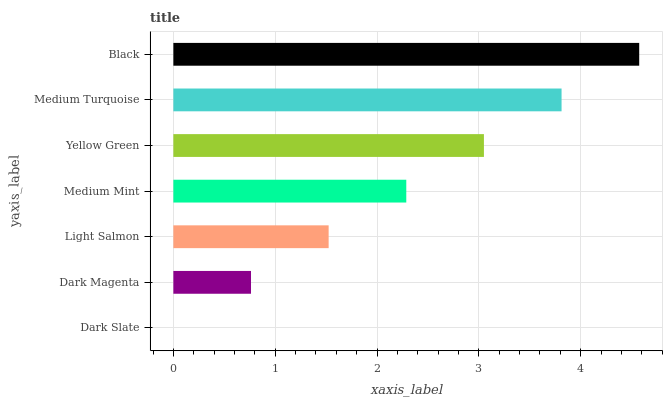Is Dark Slate the minimum?
Answer yes or no. Yes. Is Black the maximum?
Answer yes or no. Yes. Is Dark Magenta the minimum?
Answer yes or no. No. Is Dark Magenta the maximum?
Answer yes or no. No. Is Dark Magenta greater than Dark Slate?
Answer yes or no. Yes. Is Dark Slate less than Dark Magenta?
Answer yes or no. Yes. Is Dark Slate greater than Dark Magenta?
Answer yes or no. No. Is Dark Magenta less than Dark Slate?
Answer yes or no. No. Is Medium Mint the high median?
Answer yes or no. Yes. Is Medium Mint the low median?
Answer yes or no. Yes. Is Black the high median?
Answer yes or no. No. Is Dark Slate the low median?
Answer yes or no. No. 